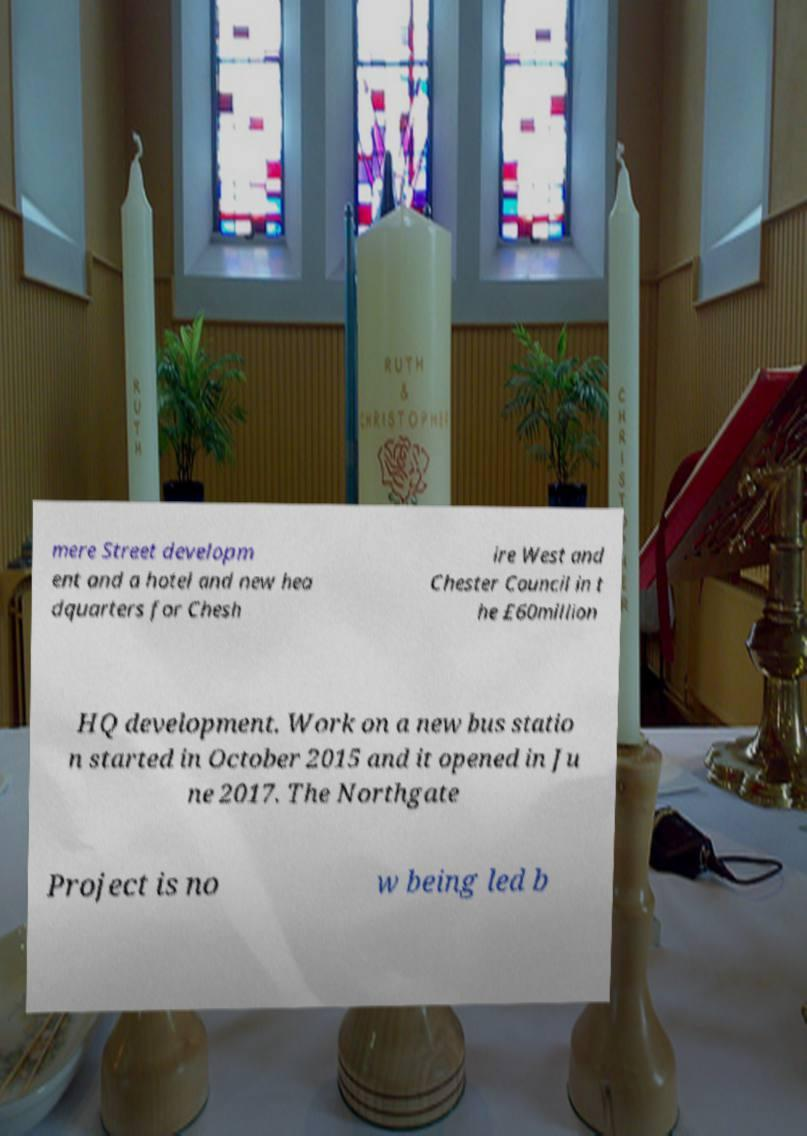Please read and relay the text visible in this image. What does it say? mere Street developm ent and a hotel and new hea dquarters for Chesh ire West and Chester Council in t he £60million HQ development. Work on a new bus statio n started in October 2015 and it opened in Ju ne 2017. The Northgate Project is no w being led b 